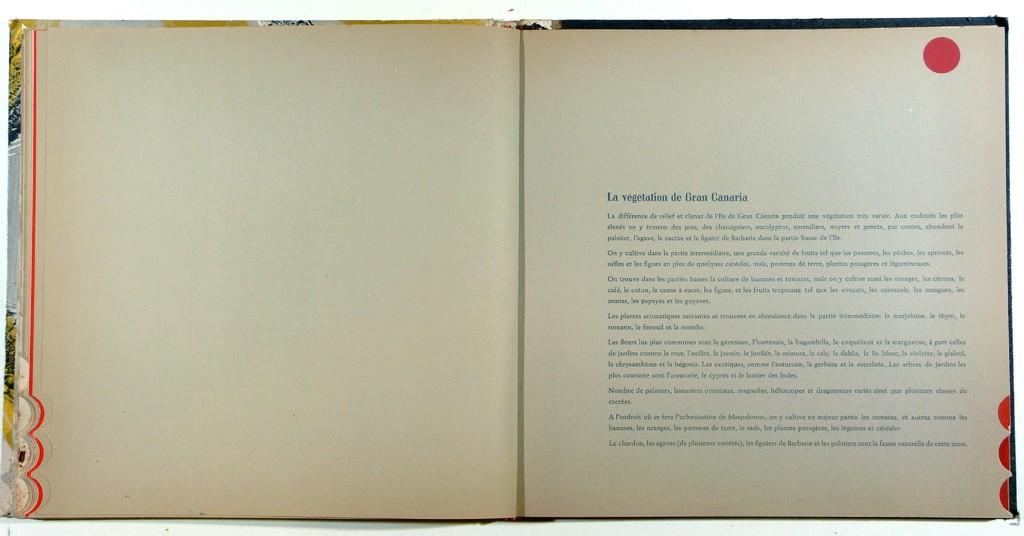What object can be seen in the image? There is a book in the image. What can be found on the right side of the book? There is writing on the right side of the book. Can you describe the red circle in the image? There is a red circle on the top of the image. What type of grass is growing in the advertisement on the book? There is no grass or advertisement present in the image; it only features a book with writing on the right side and a red circle on the top. 